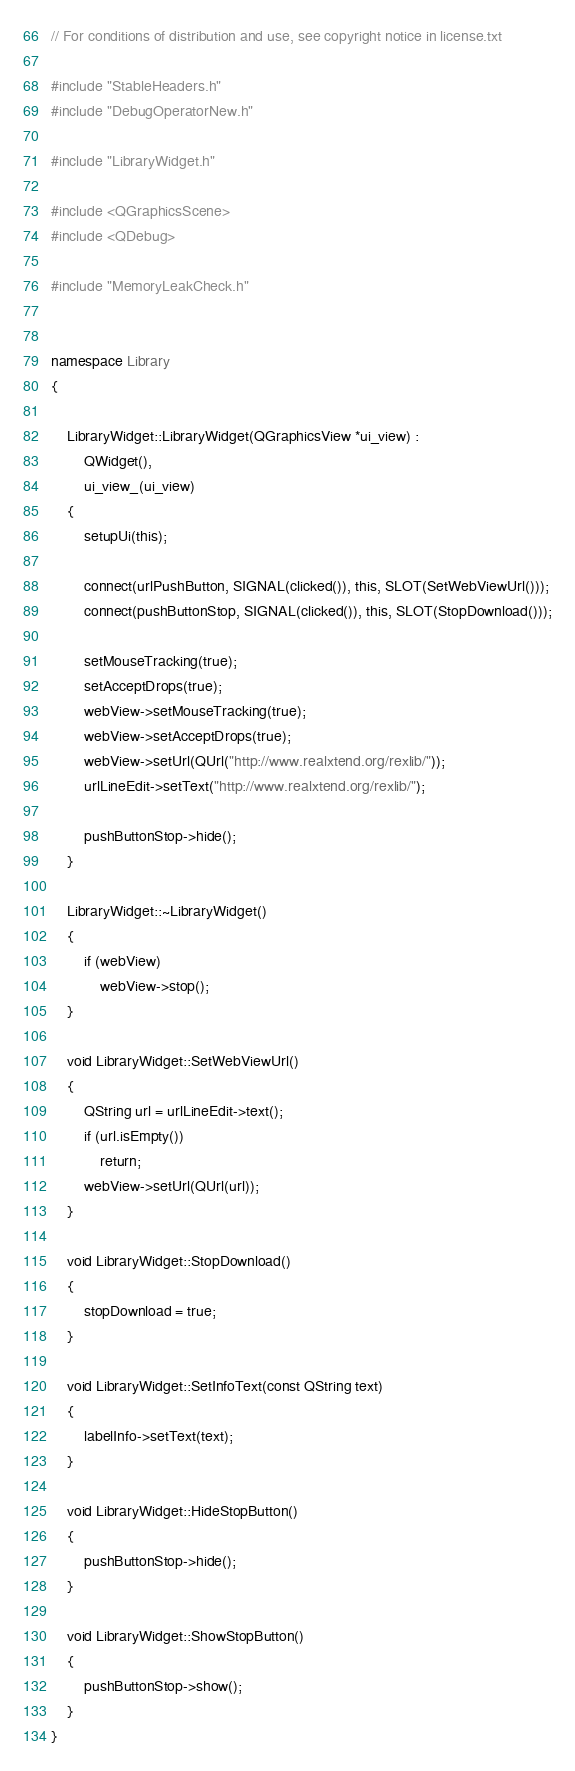<code> <loc_0><loc_0><loc_500><loc_500><_C++_>// For conditions of distribution and use, see copyright notice in license.txt

#include "StableHeaders.h"
#include "DebugOperatorNew.h"

#include "LibraryWidget.h"

#include <QGraphicsScene>
#include <QDebug>

#include "MemoryLeakCheck.h"


namespace Library
{

    LibraryWidget::LibraryWidget(QGraphicsView *ui_view) : 
        QWidget(),
        ui_view_(ui_view)
    {
        setupUi(this);        

        connect(urlPushButton, SIGNAL(clicked()), this, SLOT(SetWebViewUrl()));
        connect(pushButtonStop, SIGNAL(clicked()), this, SLOT(StopDownload()));

        setMouseTracking(true);
        setAcceptDrops(true);
        webView->setMouseTracking(true);
        webView->setAcceptDrops(true);
        webView->setUrl(QUrl("http://www.realxtend.org/rexlib/"));
        urlLineEdit->setText("http://www.realxtend.org/rexlib/");

        pushButtonStop->hide();
    }

    LibraryWidget::~LibraryWidget()
    {
        if (webView)
            webView->stop();
    }

    void LibraryWidget::SetWebViewUrl()
    {          
        QString url = urlLineEdit->text();
        if (url.isEmpty())
            return;
        webView->setUrl(QUrl(url));        
    }

    void LibraryWidget::StopDownload()
    {
        stopDownload = true;
    }

    void LibraryWidget::SetInfoText(const QString text)
    {
        labelInfo->setText(text);
    }

    void LibraryWidget::HideStopButton()
    {
        pushButtonStop->hide();
    }

    void LibraryWidget::ShowStopButton()
    {
        pushButtonStop->show();
    }
}
</code> 